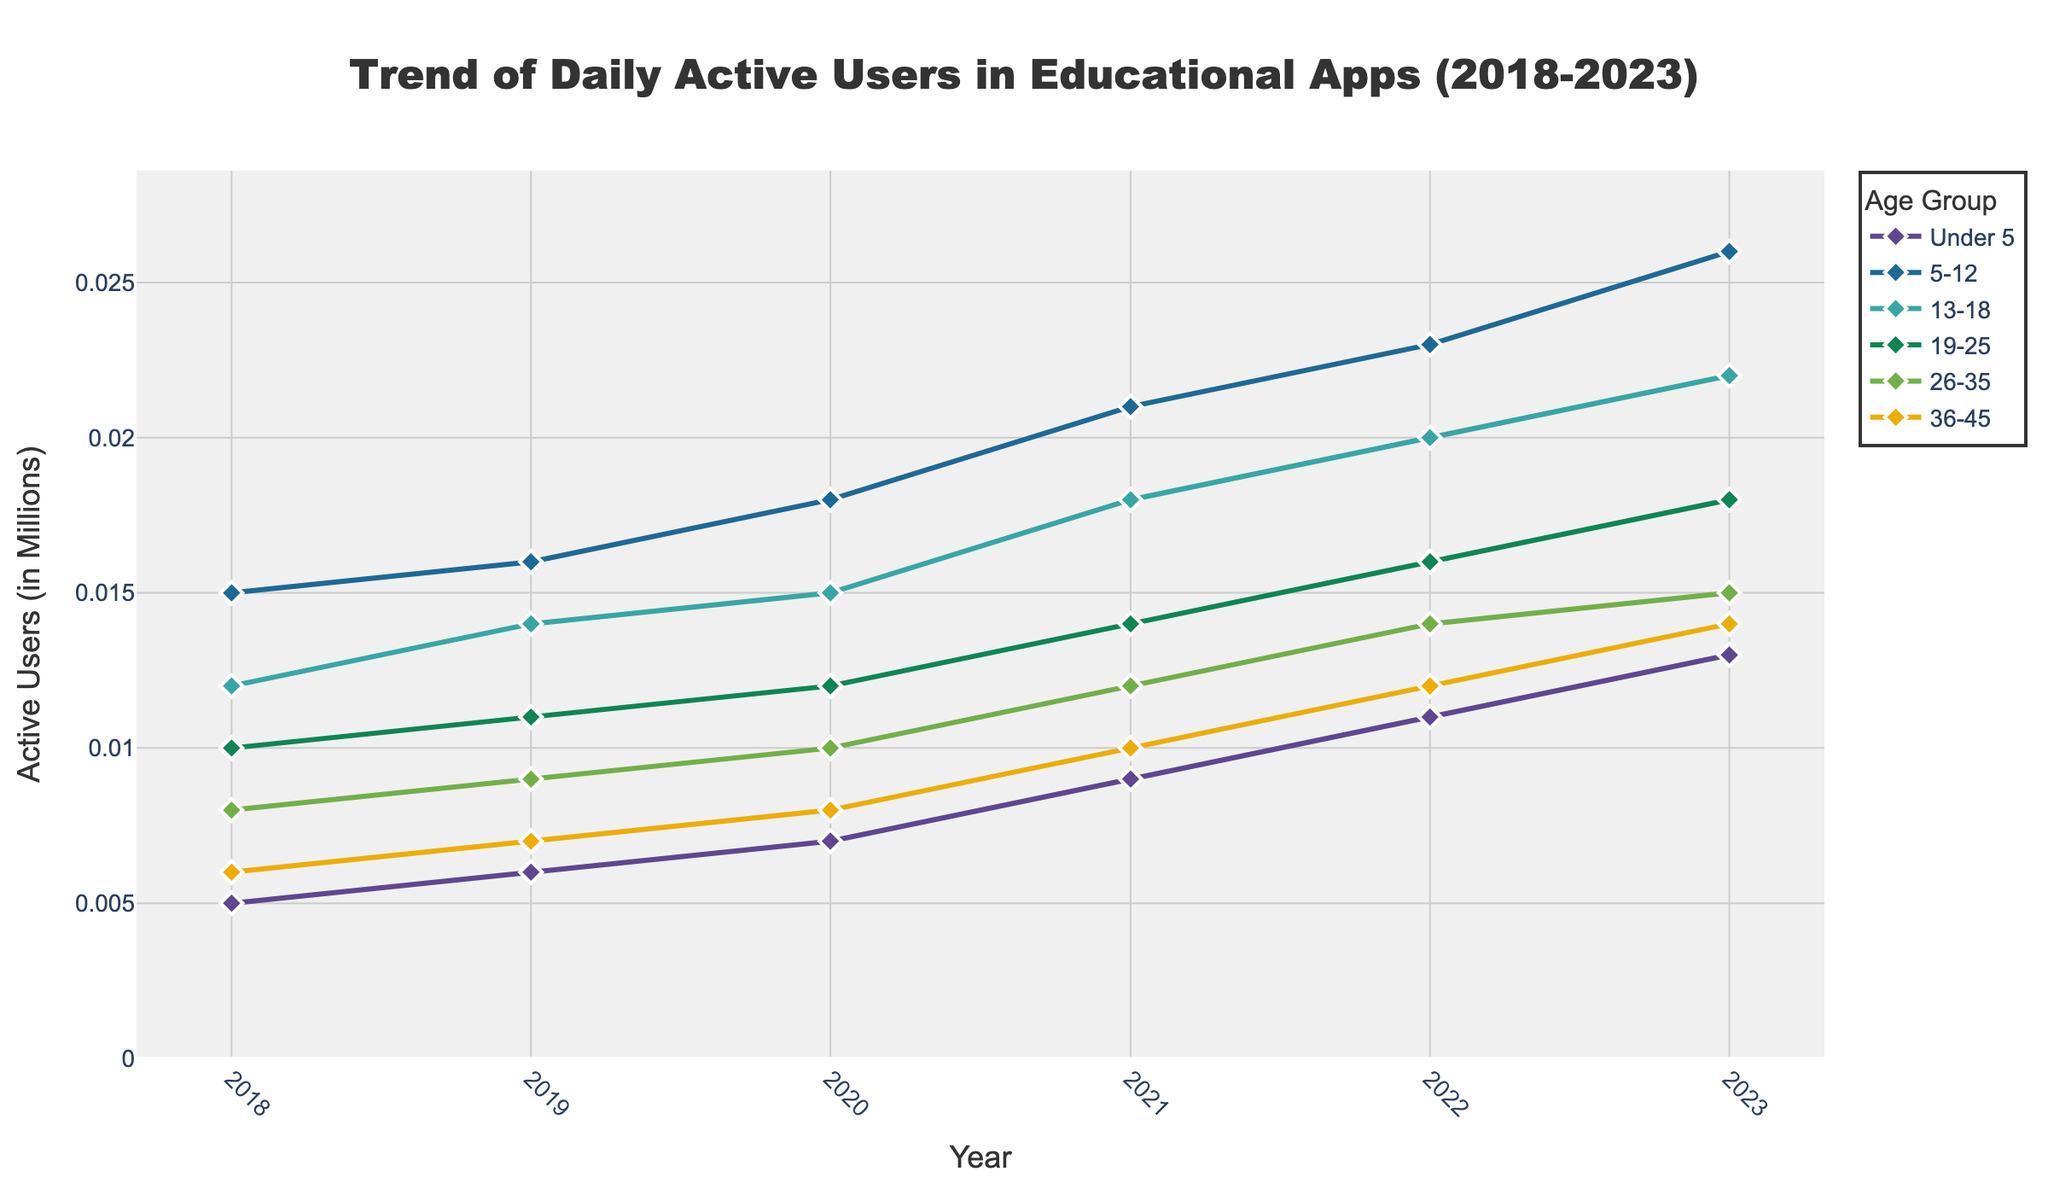What is the title of the plot? The title is typically located at the top-center of the plot and describes what the plot represents. It enables viewers to quickly understand the context of the visualization. The title of the plot is “Trend of Daily Active Users in Educational Apps (2018-2023).”
Answer: Trend of Daily Active Users in Educational Apps (2018-2023) What is the x-axis representing in the plot? The x-axis usually represents the variable that changes over time in a time series plot. In this case, it depicts the progression of years from 2018 to 2023, indicating the specific dates at which the user data was recorded.
Answer: Year What is the y-axis measuring in the plot? The y-axis shows the variable that we are interested in seeing how it changes over time. In this plot, it measures "Active Users (in Millions)," indicating the number of daily active users for each age group, scaled in millions.
Answer: Active Users (in Millions) Which age group had the highest number of active users in 2023? To identify the age group with the highest number of active users in 2023, we find the data point with the highest value on the y-axis corresponding to the year 2023 in the plot. The 5-12 age group had the highest number of active users in 2023.
Answer: 5-12 How has the number of active users in the 'Under 5' age group changed from 2018 to 2023? To understand the change, look at the trend line for the 'Under 5' age group from its start in 2018 to its end in 2023. The data shows a steady increase from 5,000 to 13,000 active users over these years.
Answer: Increased What is the average number of active users for the '5-12' age group from 2018 to 2023? Calculate the average by summing the number of active users for the '5-12' age group from 2018 to 2023 and then dividing by the number of years. Summing 15 + 16 + 18 + 21 + 23 + 26 equals 119, and dividing by 6 gives approximately 19.83 (thousands) or 0.01983 (millions).
Answer: 19.83 (thousands) or 0.01983 (millions) Which age group has shown a consistently increasing trend in the number of active users over the years? By examining the trend lines for each age group plotted on the figure, the 'Under 5', '5-12', and '13-18' age groups all show a consistent increase without significant dips or drops over the years from 2018 to 2023.
Answer: Under 5, 5-12, 13-18 Between 2018 and 2023, which age group saw the smallest increase in active users? Compare the total increase for each age group by subtracting the number of active users in 2018 from the number of 2023. For the 36-45 age group, the increase is minimal, from 6000 to 14000, an increase of 8000.
Answer: 36-45 In 2020, which age group had the third highest number of active users? To find this, identify the data points for 2020 and rank them. The '5-12' age group ranked first, '13-18' second, and '19-25' third with 12,000 active users.
Answer: 19-25 